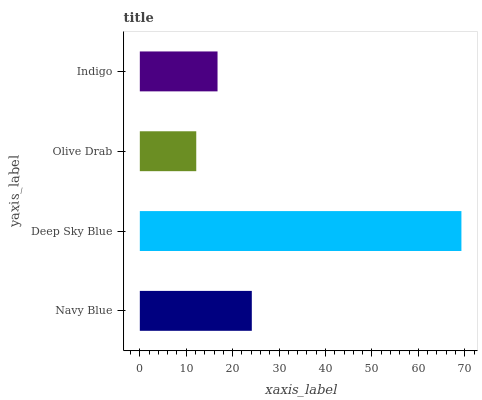Is Olive Drab the minimum?
Answer yes or no. Yes. Is Deep Sky Blue the maximum?
Answer yes or no. Yes. Is Deep Sky Blue the minimum?
Answer yes or no. No. Is Olive Drab the maximum?
Answer yes or no. No. Is Deep Sky Blue greater than Olive Drab?
Answer yes or no. Yes. Is Olive Drab less than Deep Sky Blue?
Answer yes or no. Yes. Is Olive Drab greater than Deep Sky Blue?
Answer yes or no. No. Is Deep Sky Blue less than Olive Drab?
Answer yes or no. No. Is Navy Blue the high median?
Answer yes or no. Yes. Is Indigo the low median?
Answer yes or no. Yes. Is Deep Sky Blue the high median?
Answer yes or no. No. Is Deep Sky Blue the low median?
Answer yes or no. No. 